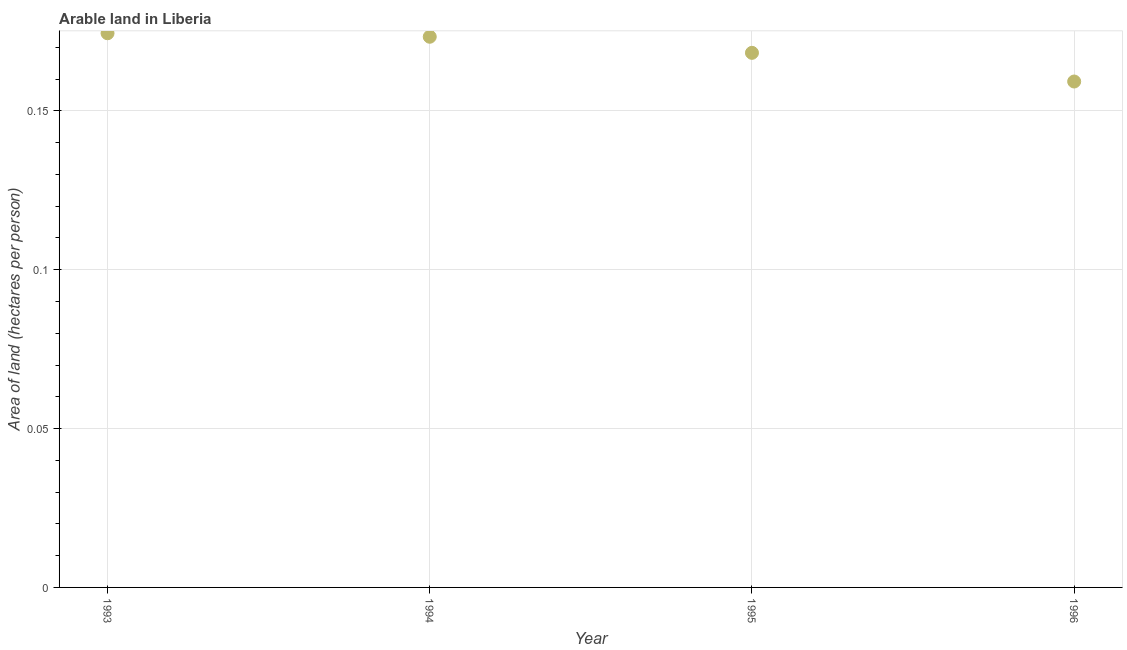What is the area of arable land in 1993?
Give a very brief answer. 0.17. Across all years, what is the maximum area of arable land?
Provide a short and direct response. 0.17. Across all years, what is the minimum area of arable land?
Give a very brief answer. 0.16. In which year was the area of arable land minimum?
Ensure brevity in your answer.  1996. What is the sum of the area of arable land?
Keep it short and to the point. 0.68. What is the difference between the area of arable land in 1993 and 1996?
Offer a terse response. 0.02. What is the average area of arable land per year?
Keep it short and to the point. 0.17. What is the median area of arable land?
Your answer should be very brief. 0.17. In how many years, is the area of arable land greater than 0.13 hectares per person?
Your answer should be compact. 4. What is the ratio of the area of arable land in 1994 to that in 1995?
Keep it short and to the point. 1.03. Is the area of arable land in 1993 less than that in 1996?
Your answer should be very brief. No. Is the difference between the area of arable land in 1993 and 1996 greater than the difference between any two years?
Provide a short and direct response. Yes. What is the difference between the highest and the second highest area of arable land?
Offer a terse response. 0. What is the difference between the highest and the lowest area of arable land?
Make the answer very short. 0.02. Does the area of arable land monotonically increase over the years?
Provide a short and direct response. No. How many years are there in the graph?
Give a very brief answer. 4. Does the graph contain any zero values?
Give a very brief answer. No. What is the title of the graph?
Offer a terse response. Arable land in Liberia. What is the label or title of the Y-axis?
Offer a terse response. Area of land (hectares per person). What is the Area of land (hectares per person) in 1993?
Ensure brevity in your answer.  0.17. What is the Area of land (hectares per person) in 1994?
Make the answer very short. 0.17. What is the Area of land (hectares per person) in 1995?
Your response must be concise. 0.17. What is the Area of land (hectares per person) in 1996?
Provide a succinct answer. 0.16. What is the difference between the Area of land (hectares per person) in 1993 and 1994?
Give a very brief answer. 0. What is the difference between the Area of land (hectares per person) in 1993 and 1995?
Keep it short and to the point. 0.01. What is the difference between the Area of land (hectares per person) in 1993 and 1996?
Your response must be concise. 0.02. What is the difference between the Area of land (hectares per person) in 1994 and 1995?
Ensure brevity in your answer.  0.01. What is the difference between the Area of land (hectares per person) in 1994 and 1996?
Give a very brief answer. 0.01. What is the difference between the Area of land (hectares per person) in 1995 and 1996?
Make the answer very short. 0.01. What is the ratio of the Area of land (hectares per person) in 1993 to that in 1994?
Your response must be concise. 1.01. What is the ratio of the Area of land (hectares per person) in 1993 to that in 1996?
Offer a very short reply. 1.09. What is the ratio of the Area of land (hectares per person) in 1994 to that in 1996?
Give a very brief answer. 1.09. What is the ratio of the Area of land (hectares per person) in 1995 to that in 1996?
Make the answer very short. 1.06. 